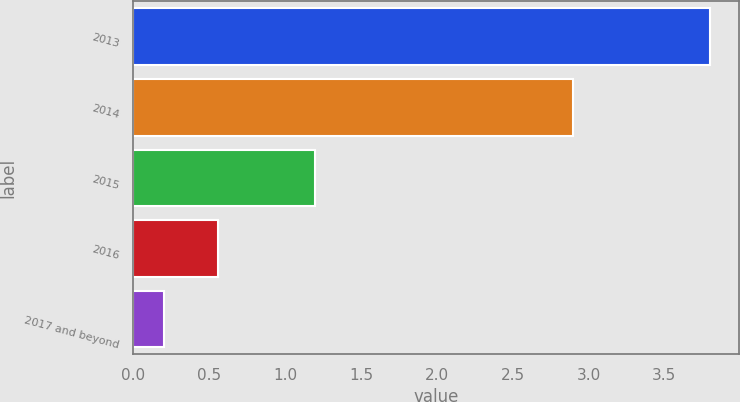<chart> <loc_0><loc_0><loc_500><loc_500><bar_chart><fcel>2013<fcel>2014<fcel>2015<fcel>2016<fcel>2017 and beyond<nl><fcel>3.8<fcel>2.9<fcel>1.2<fcel>0.56<fcel>0.2<nl></chart> 